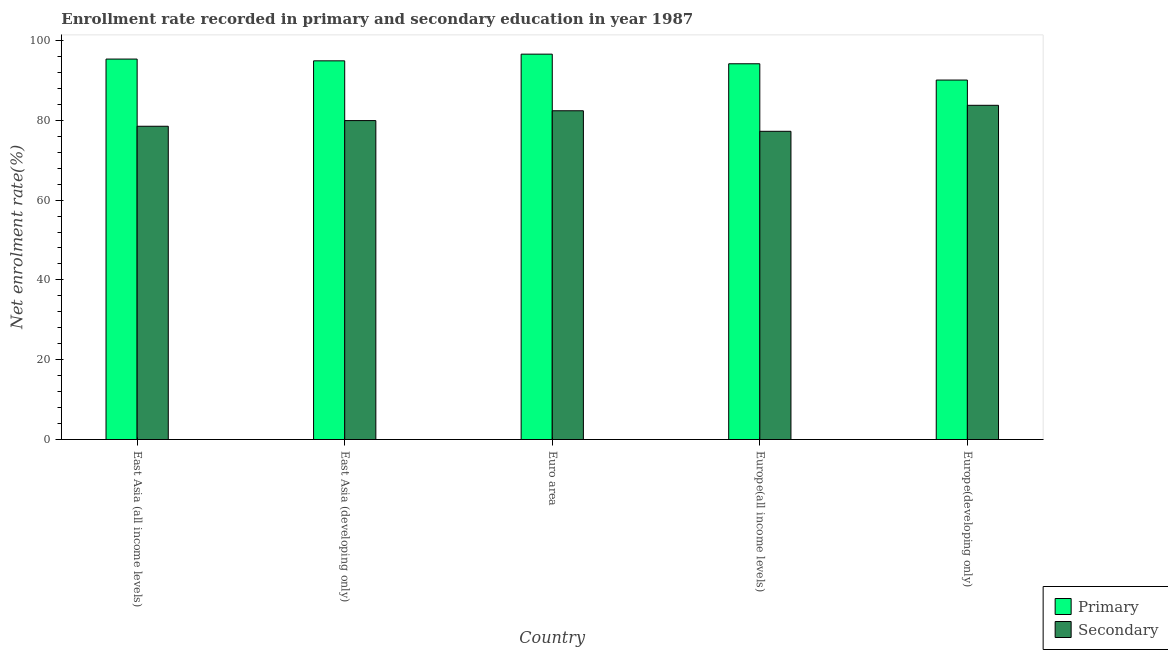How many different coloured bars are there?
Make the answer very short. 2. How many groups of bars are there?
Make the answer very short. 5. Are the number of bars per tick equal to the number of legend labels?
Your answer should be compact. Yes. How many bars are there on the 5th tick from the right?
Keep it short and to the point. 2. What is the label of the 2nd group of bars from the left?
Keep it short and to the point. East Asia (developing only). What is the enrollment rate in secondary education in Euro area?
Your response must be concise. 82.38. Across all countries, what is the maximum enrollment rate in primary education?
Offer a very short reply. 96.57. Across all countries, what is the minimum enrollment rate in primary education?
Ensure brevity in your answer.  90.08. In which country was the enrollment rate in secondary education maximum?
Make the answer very short. Europe(developing only). In which country was the enrollment rate in primary education minimum?
Your answer should be very brief. Europe(developing only). What is the total enrollment rate in secondary education in the graph?
Your response must be concise. 401.8. What is the difference between the enrollment rate in primary education in Euro area and that in Europe(all income levels)?
Provide a short and direct response. 2.41. What is the difference between the enrollment rate in secondary education in Euro area and the enrollment rate in primary education in East Asia (all income levels)?
Provide a short and direct response. -12.95. What is the average enrollment rate in secondary education per country?
Provide a short and direct response. 80.36. What is the difference between the enrollment rate in secondary education and enrollment rate in primary education in East Asia (all income levels)?
Make the answer very short. -16.83. What is the ratio of the enrollment rate in primary education in East Asia (all income levels) to that in East Asia (developing only)?
Your answer should be compact. 1. Is the enrollment rate in secondary education in Euro area less than that in Europe(developing only)?
Ensure brevity in your answer.  Yes. What is the difference between the highest and the second highest enrollment rate in primary education?
Provide a succinct answer. 1.24. What is the difference between the highest and the lowest enrollment rate in secondary education?
Offer a very short reply. 6.52. In how many countries, is the enrollment rate in secondary education greater than the average enrollment rate in secondary education taken over all countries?
Keep it short and to the point. 2. What does the 1st bar from the left in Europe(developing only) represents?
Keep it short and to the point. Primary. What does the 2nd bar from the right in Europe(developing only) represents?
Your response must be concise. Primary. How many bars are there?
Your answer should be very brief. 10. Are all the bars in the graph horizontal?
Keep it short and to the point. No. What is the difference between two consecutive major ticks on the Y-axis?
Ensure brevity in your answer.  20. Are the values on the major ticks of Y-axis written in scientific E-notation?
Your answer should be very brief. No. Does the graph contain grids?
Your answer should be very brief. No. How many legend labels are there?
Give a very brief answer. 2. How are the legend labels stacked?
Your answer should be compact. Vertical. What is the title of the graph?
Give a very brief answer. Enrollment rate recorded in primary and secondary education in year 1987. Does "Travel services" appear as one of the legend labels in the graph?
Keep it short and to the point. No. What is the label or title of the Y-axis?
Your answer should be very brief. Net enrolment rate(%). What is the Net enrolment rate(%) of Primary in East Asia (all income levels)?
Offer a terse response. 95.34. What is the Net enrolment rate(%) in Secondary in East Asia (all income levels)?
Offer a very short reply. 78.5. What is the Net enrolment rate(%) of Primary in East Asia (developing only)?
Make the answer very short. 94.89. What is the Net enrolment rate(%) in Secondary in East Asia (developing only)?
Make the answer very short. 79.92. What is the Net enrolment rate(%) in Primary in Euro area?
Offer a terse response. 96.57. What is the Net enrolment rate(%) of Secondary in Euro area?
Make the answer very short. 82.38. What is the Net enrolment rate(%) of Primary in Europe(all income levels)?
Offer a terse response. 94.16. What is the Net enrolment rate(%) in Secondary in Europe(all income levels)?
Your answer should be very brief. 77.23. What is the Net enrolment rate(%) in Primary in Europe(developing only)?
Your response must be concise. 90.08. What is the Net enrolment rate(%) of Secondary in Europe(developing only)?
Make the answer very short. 83.75. Across all countries, what is the maximum Net enrolment rate(%) in Primary?
Provide a succinct answer. 96.57. Across all countries, what is the maximum Net enrolment rate(%) in Secondary?
Keep it short and to the point. 83.75. Across all countries, what is the minimum Net enrolment rate(%) in Primary?
Provide a short and direct response. 90.08. Across all countries, what is the minimum Net enrolment rate(%) in Secondary?
Provide a short and direct response. 77.23. What is the total Net enrolment rate(%) of Primary in the graph?
Ensure brevity in your answer.  471.04. What is the total Net enrolment rate(%) of Secondary in the graph?
Offer a very short reply. 401.8. What is the difference between the Net enrolment rate(%) in Primary in East Asia (all income levels) and that in East Asia (developing only)?
Ensure brevity in your answer.  0.44. What is the difference between the Net enrolment rate(%) in Secondary in East Asia (all income levels) and that in East Asia (developing only)?
Provide a short and direct response. -1.42. What is the difference between the Net enrolment rate(%) of Primary in East Asia (all income levels) and that in Euro area?
Your response must be concise. -1.24. What is the difference between the Net enrolment rate(%) in Secondary in East Asia (all income levels) and that in Euro area?
Offer a terse response. -3.88. What is the difference between the Net enrolment rate(%) of Primary in East Asia (all income levels) and that in Europe(all income levels)?
Provide a succinct answer. 1.18. What is the difference between the Net enrolment rate(%) of Secondary in East Asia (all income levels) and that in Europe(all income levels)?
Make the answer very short. 1.27. What is the difference between the Net enrolment rate(%) of Primary in East Asia (all income levels) and that in Europe(developing only)?
Your answer should be compact. 5.26. What is the difference between the Net enrolment rate(%) in Secondary in East Asia (all income levels) and that in Europe(developing only)?
Your response must be concise. -5.25. What is the difference between the Net enrolment rate(%) of Primary in East Asia (developing only) and that in Euro area?
Keep it short and to the point. -1.68. What is the difference between the Net enrolment rate(%) in Secondary in East Asia (developing only) and that in Euro area?
Provide a short and direct response. -2.46. What is the difference between the Net enrolment rate(%) of Primary in East Asia (developing only) and that in Europe(all income levels)?
Your response must be concise. 0.74. What is the difference between the Net enrolment rate(%) of Secondary in East Asia (developing only) and that in Europe(all income levels)?
Provide a short and direct response. 2.69. What is the difference between the Net enrolment rate(%) of Primary in East Asia (developing only) and that in Europe(developing only)?
Your response must be concise. 4.81. What is the difference between the Net enrolment rate(%) in Secondary in East Asia (developing only) and that in Europe(developing only)?
Ensure brevity in your answer.  -3.83. What is the difference between the Net enrolment rate(%) of Primary in Euro area and that in Europe(all income levels)?
Ensure brevity in your answer.  2.41. What is the difference between the Net enrolment rate(%) of Secondary in Euro area and that in Europe(all income levels)?
Provide a succinct answer. 5.15. What is the difference between the Net enrolment rate(%) of Primary in Euro area and that in Europe(developing only)?
Make the answer very short. 6.49. What is the difference between the Net enrolment rate(%) in Secondary in Euro area and that in Europe(developing only)?
Ensure brevity in your answer.  -1.37. What is the difference between the Net enrolment rate(%) of Primary in Europe(all income levels) and that in Europe(developing only)?
Your answer should be very brief. 4.08. What is the difference between the Net enrolment rate(%) in Secondary in Europe(all income levels) and that in Europe(developing only)?
Provide a succinct answer. -6.52. What is the difference between the Net enrolment rate(%) of Primary in East Asia (all income levels) and the Net enrolment rate(%) of Secondary in East Asia (developing only)?
Keep it short and to the point. 15.41. What is the difference between the Net enrolment rate(%) of Primary in East Asia (all income levels) and the Net enrolment rate(%) of Secondary in Euro area?
Give a very brief answer. 12.95. What is the difference between the Net enrolment rate(%) of Primary in East Asia (all income levels) and the Net enrolment rate(%) of Secondary in Europe(all income levels)?
Give a very brief answer. 18.1. What is the difference between the Net enrolment rate(%) in Primary in East Asia (all income levels) and the Net enrolment rate(%) in Secondary in Europe(developing only)?
Offer a terse response. 11.58. What is the difference between the Net enrolment rate(%) of Primary in East Asia (developing only) and the Net enrolment rate(%) of Secondary in Euro area?
Provide a short and direct response. 12.51. What is the difference between the Net enrolment rate(%) in Primary in East Asia (developing only) and the Net enrolment rate(%) in Secondary in Europe(all income levels)?
Give a very brief answer. 17.66. What is the difference between the Net enrolment rate(%) in Primary in East Asia (developing only) and the Net enrolment rate(%) in Secondary in Europe(developing only)?
Provide a short and direct response. 11.14. What is the difference between the Net enrolment rate(%) of Primary in Euro area and the Net enrolment rate(%) of Secondary in Europe(all income levels)?
Provide a succinct answer. 19.34. What is the difference between the Net enrolment rate(%) of Primary in Euro area and the Net enrolment rate(%) of Secondary in Europe(developing only)?
Your answer should be very brief. 12.82. What is the difference between the Net enrolment rate(%) of Primary in Europe(all income levels) and the Net enrolment rate(%) of Secondary in Europe(developing only)?
Offer a terse response. 10.41. What is the average Net enrolment rate(%) in Primary per country?
Your answer should be very brief. 94.21. What is the average Net enrolment rate(%) in Secondary per country?
Offer a terse response. 80.36. What is the difference between the Net enrolment rate(%) of Primary and Net enrolment rate(%) of Secondary in East Asia (all income levels)?
Keep it short and to the point. 16.83. What is the difference between the Net enrolment rate(%) of Primary and Net enrolment rate(%) of Secondary in East Asia (developing only)?
Provide a succinct answer. 14.97. What is the difference between the Net enrolment rate(%) of Primary and Net enrolment rate(%) of Secondary in Euro area?
Make the answer very short. 14.19. What is the difference between the Net enrolment rate(%) of Primary and Net enrolment rate(%) of Secondary in Europe(all income levels)?
Offer a very short reply. 16.92. What is the difference between the Net enrolment rate(%) of Primary and Net enrolment rate(%) of Secondary in Europe(developing only)?
Provide a short and direct response. 6.33. What is the ratio of the Net enrolment rate(%) of Primary in East Asia (all income levels) to that in East Asia (developing only)?
Your answer should be very brief. 1. What is the ratio of the Net enrolment rate(%) of Secondary in East Asia (all income levels) to that in East Asia (developing only)?
Offer a terse response. 0.98. What is the ratio of the Net enrolment rate(%) in Primary in East Asia (all income levels) to that in Euro area?
Keep it short and to the point. 0.99. What is the ratio of the Net enrolment rate(%) in Secondary in East Asia (all income levels) to that in Euro area?
Your answer should be very brief. 0.95. What is the ratio of the Net enrolment rate(%) in Primary in East Asia (all income levels) to that in Europe(all income levels)?
Provide a short and direct response. 1.01. What is the ratio of the Net enrolment rate(%) of Secondary in East Asia (all income levels) to that in Europe(all income levels)?
Keep it short and to the point. 1.02. What is the ratio of the Net enrolment rate(%) of Primary in East Asia (all income levels) to that in Europe(developing only)?
Your response must be concise. 1.06. What is the ratio of the Net enrolment rate(%) in Secondary in East Asia (all income levels) to that in Europe(developing only)?
Your answer should be very brief. 0.94. What is the ratio of the Net enrolment rate(%) of Primary in East Asia (developing only) to that in Euro area?
Keep it short and to the point. 0.98. What is the ratio of the Net enrolment rate(%) in Secondary in East Asia (developing only) to that in Euro area?
Keep it short and to the point. 0.97. What is the ratio of the Net enrolment rate(%) of Secondary in East Asia (developing only) to that in Europe(all income levels)?
Make the answer very short. 1.03. What is the ratio of the Net enrolment rate(%) of Primary in East Asia (developing only) to that in Europe(developing only)?
Provide a succinct answer. 1.05. What is the ratio of the Net enrolment rate(%) of Secondary in East Asia (developing only) to that in Europe(developing only)?
Give a very brief answer. 0.95. What is the ratio of the Net enrolment rate(%) of Primary in Euro area to that in Europe(all income levels)?
Offer a very short reply. 1.03. What is the ratio of the Net enrolment rate(%) in Secondary in Euro area to that in Europe(all income levels)?
Make the answer very short. 1.07. What is the ratio of the Net enrolment rate(%) of Primary in Euro area to that in Europe(developing only)?
Ensure brevity in your answer.  1.07. What is the ratio of the Net enrolment rate(%) in Secondary in Euro area to that in Europe(developing only)?
Provide a short and direct response. 0.98. What is the ratio of the Net enrolment rate(%) of Primary in Europe(all income levels) to that in Europe(developing only)?
Offer a very short reply. 1.05. What is the ratio of the Net enrolment rate(%) of Secondary in Europe(all income levels) to that in Europe(developing only)?
Your answer should be compact. 0.92. What is the difference between the highest and the second highest Net enrolment rate(%) of Primary?
Keep it short and to the point. 1.24. What is the difference between the highest and the second highest Net enrolment rate(%) in Secondary?
Keep it short and to the point. 1.37. What is the difference between the highest and the lowest Net enrolment rate(%) in Primary?
Provide a short and direct response. 6.49. What is the difference between the highest and the lowest Net enrolment rate(%) of Secondary?
Your response must be concise. 6.52. 